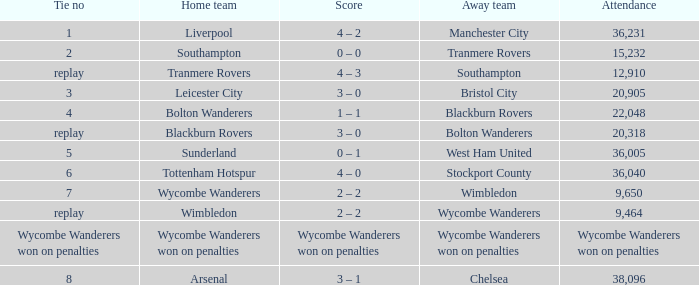What was the score for the match where the home team was Leicester City? 3 – 0. 